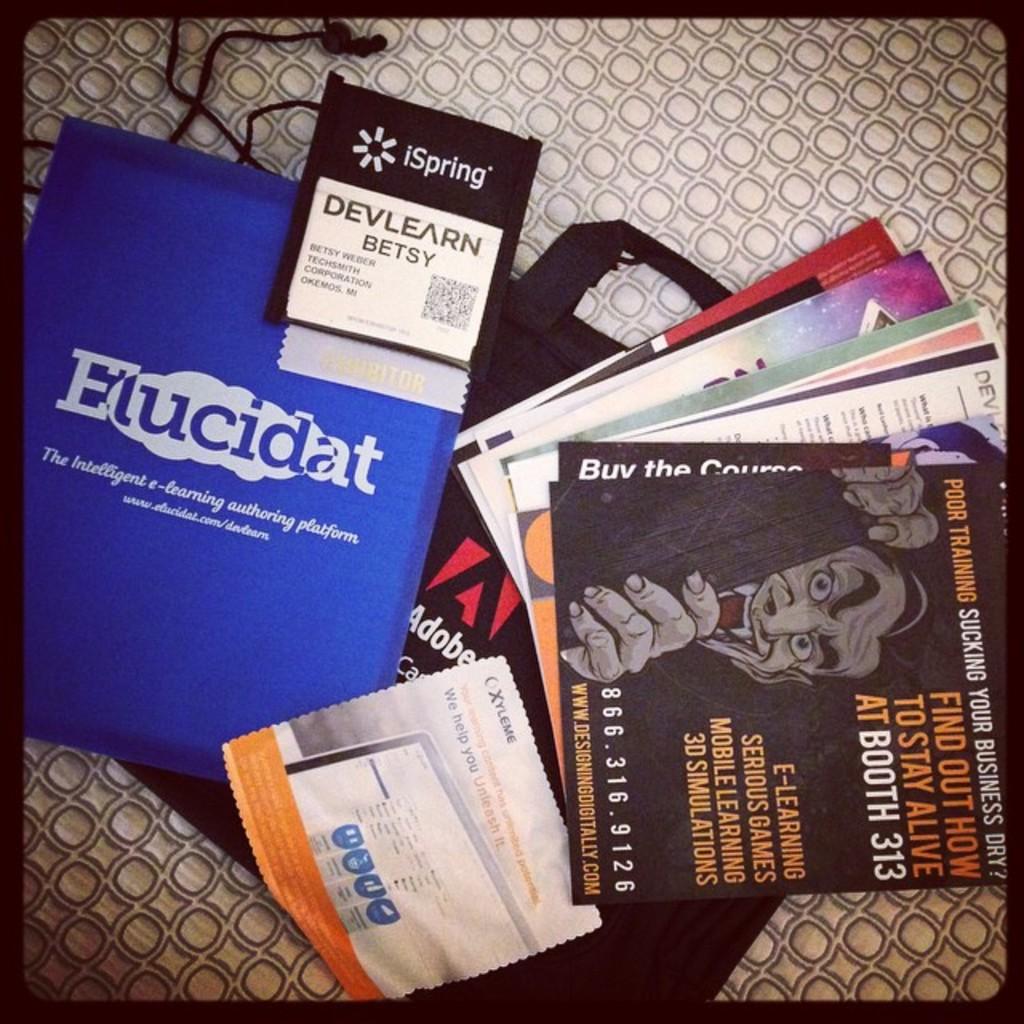Which company made the literature in the blue book?
Provide a succinct answer. Elucidat. 